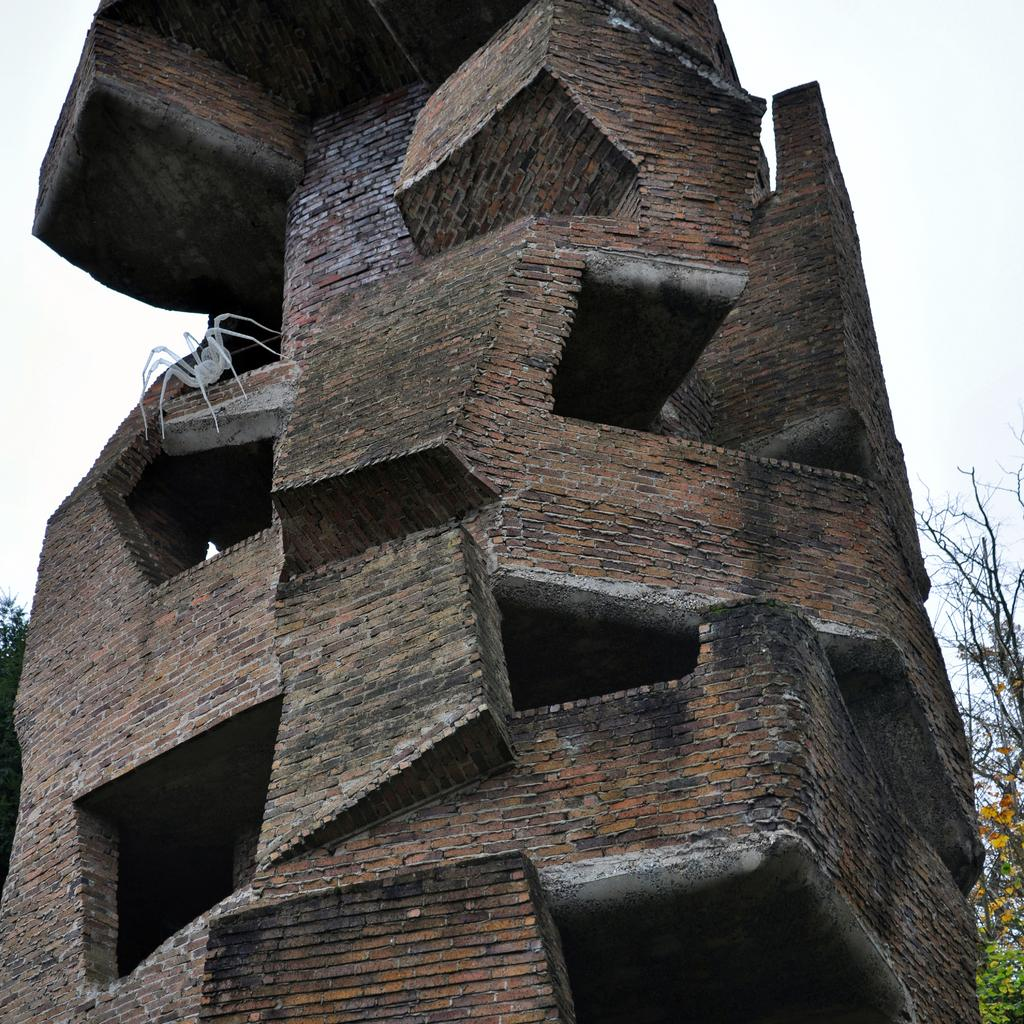What type of structure is present in the image? There is a building in the image. Are there any living organisms visible in the image? Yes, there is a spider in the image. What type of vegetation can be seen in the image? There are trees in the image. What can be seen in the background of the image? The sky is visible in the background of the image. What is the current stocking price of the building in the image? There is no information about the stocking price of the building in the image, as it is not related to the image's content. 